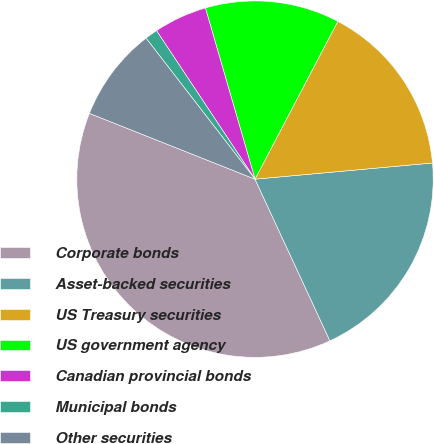Convert chart to OTSL. <chart><loc_0><loc_0><loc_500><loc_500><pie_chart><fcel>Corporate bonds<fcel>Asset-backed securities<fcel>US Treasury securities<fcel>US government agency<fcel>Canadian provincial bonds<fcel>Municipal bonds<fcel>Other securities<nl><fcel>37.92%<fcel>19.54%<fcel>15.86%<fcel>12.18%<fcel>4.83%<fcel>1.15%<fcel>8.51%<nl></chart> 